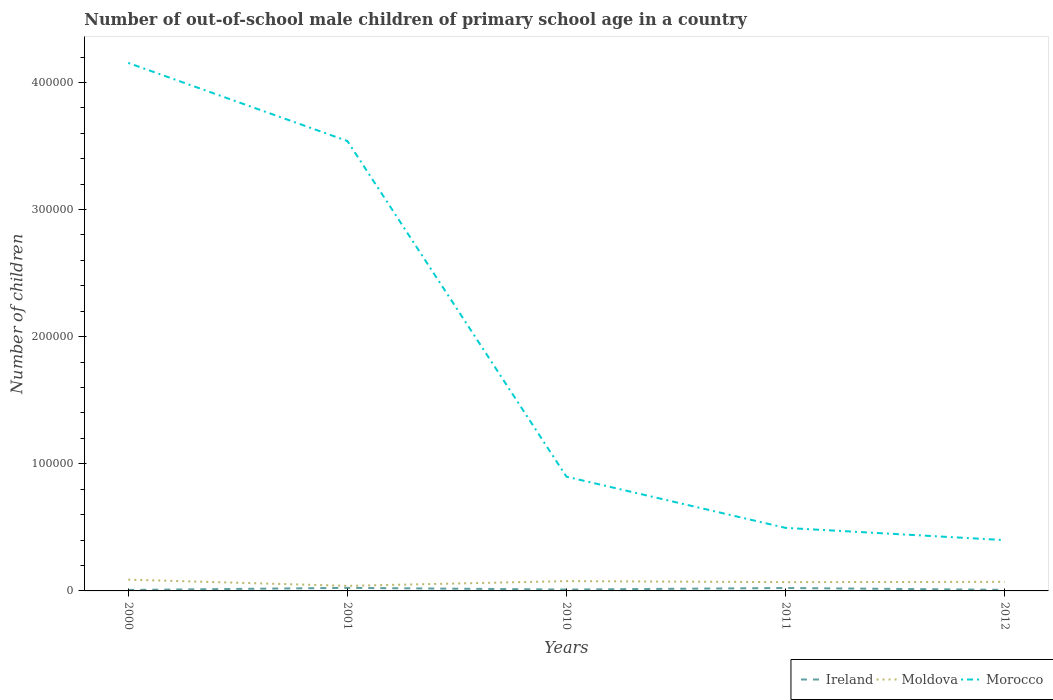Is the number of lines equal to the number of legend labels?
Your answer should be compact. Yes. Across all years, what is the maximum number of out-of-school male children in Ireland?
Offer a terse response. 761. In which year was the number of out-of-school male children in Morocco maximum?
Make the answer very short. 2012. What is the total number of out-of-school male children in Morocco in the graph?
Offer a very short reply. 3.04e+05. What is the difference between the highest and the second highest number of out-of-school male children in Ireland?
Provide a short and direct response. 1641. What is the difference between the highest and the lowest number of out-of-school male children in Moldova?
Make the answer very short. 3. How many lines are there?
Your answer should be compact. 3. What is the difference between two consecutive major ticks on the Y-axis?
Your response must be concise. 1.00e+05. Where does the legend appear in the graph?
Your response must be concise. Bottom right. How many legend labels are there?
Make the answer very short. 3. What is the title of the graph?
Your answer should be compact. Number of out-of-school male children of primary school age in a country. Does "Malaysia" appear as one of the legend labels in the graph?
Keep it short and to the point. No. What is the label or title of the X-axis?
Your answer should be very brief. Years. What is the label or title of the Y-axis?
Your response must be concise. Number of children. What is the Number of children of Ireland in 2000?
Give a very brief answer. 761. What is the Number of children in Moldova in 2000?
Offer a terse response. 8873. What is the Number of children of Morocco in 2000?
Provide a succinct answer. 4.15e+05. What is the Number of children in Ireland in 2001?
Keep it short and to the point. 2402. What is the Number of children of Moldova in 2001?
Make the answer very short. 3993. What is the Number of children of Morocco in 2001?
Your response must be concise. 3.54e+05. What is the Number of children in Ireland in 2010?
Provide a succinct answer. 1077. What is the Number of children in Moldova in 2010?
Offer a very short reply. 7708. What is the Number of children in Morocco in 2010?
Your response must be concise. 8.99e+04. What is the Number of children in Ireland in 2011?
Give a very brief answer. 2292. What is the Number of children in Moldova in 2011?
Your response must be concise. 6917. What is the Number of children of Morocco in 2011?
Your response must be concise. 4.96e+04. What is the Number of children in Ireland in 2012?
Give a very brief answer. 857. What is the Number of children in Moldova in 2012?
Make the answer very short. 7138. What is the Number of children of Morocco in 2012?
Ensure brevity in your answer.  4.00e+04. Across all years, what is the maximum Number of children in Ireland?
Keep it short and to the point. 2402. Across all years, what is the maximum Number of children of Moldova?
Offer a very short reply. 8873. Across all years, what is the maximum Number of children in Morocco?
Your response must be concise. 4.15e+05. Across all years, what is the minimum Number of children in Ireland?
Offer a very short reply. 761. Across all years, what is the minimum Number of children in Moldova?
Provide a short and direct response. 3993. Across all years, what is the minimum Number of children of Morocco?
Provide a short and direct response. 4.00e+04. What is the total Number of children of Ireland in the graph?
Provide a short and direct response. 7389. What is the total Number of children of Moldova in the graph?
Your answer should be compact. 3.46e+04. What is the total Number of children in Morocco in the graph?
Provide a succinct answer. 9.49e+05. What is the difference between the Number of children in Ireland in 2000 and that in 2001?
Provide a short and direct response. -1641. What is the difference between the Number of children of Moldova in 2000 and that in 2001?
Offer a very short reply. 4880. What is the difference between the Number of children of Morocco in 2000 and that in 2001?
Make the answer very short. 6.14e+04. What is the difference between the Number of children of Ireland in 2000 and that in 2010?
Keep it short and to the point. -316. What is the difference between the Number of children of Moldova in 2000 and that in 2010?
Ensure brevity in your answer.  1165. What is the difference between the Number of children in Morocco in 2000 and that in 2010?
Offer a terse response. 3.26e+05. What is the difference between the Number of children in Ireland in 2000 and that in 2011?
Ensure brevity in your answer.  -1531. What is the difference between the Number of children of Moldova in 2000 and that in 2011?
Give a very brief answer. 1956. What is the difference between the Number of children of Morocco in 2000 and that in 2011?
Ensure brevity in your answer.  3.66e+05. What is the difference between the Number of children in Ireland in 2000 and that in 2012?
Make the answer very short. -96. What is the difference between the Number of children in Moldova in 2000 and that in 2012?
Offer a terse response. 1735. What is the difference between the Number of children in Morocco in 2000 and that in 2012?
Make the answer very short. 3.75e+05. What is the difference between the Number of children of Ireland in 2001 and that in 2010?
Provide a succinct answer. 1325. What is the difference between the Number of children in Moldova in 2001 and that in 2010?
Your answer should be very brief. -3715. What is the difference between the Number of children in Morocco in 2001 and that in 2010?
Your answer should be compact. 2.64e+05. What is the difference between the Number of children in Ireland in 2001 and that in 2011?
Your answer should be compact. 110. What is the difference between the Number of children in Moldova in 2001 and that in 2011?
Provide a short and direct response. -2924. What is the difference between the Number of children in Morocco in 2001 and that in 2011?
Provide a succinct answer. 3.04e+05. What is the difference between the Number of children of Ireland in 2001 and that in 2012?
Your answer should be very brief. 1545. What is the difference between the Number of children of Moldova in 2001 and that in 2012?
Provide a succinct answer. -3145. What is the difference between the Number of children in Morocco in 2001 and that in 2012?
Your answer should be very brief. 3.14e+05. What is the difference between the Number of children in Ireland in 2010 and that in 2011?
Offer a terse response. -1215. What is the difference between the Number of children of Moldova in 2010 and that in 2011?
Give a very brief answer. 791. What is the difference between the Number of children of Morocco in 2010 and that in 2011?
Keep it short and to the point. 4.03e+04. What is the difference between the Number of children of Ireland in 2010 and that in 2012?
Give a very brief answer. 220. What is the difference between the Number of children of Moldova in 2010 and that in 2012?
Provide a succinct answer. 570. What is the difference between the Number of children in Morocco in 2010 and that in 2012?
Make the answer very short. 4.99e+04. What is the difference between the Number of children in Ireland in 2011 and that in 2012?
Ensure brevity in your answer.  1435. What is the difference between the Number of children of Moldova in 2011 and that in 2012?
Ensure brevity in your answer.  -221. What is the difference between the Number of children in Morocco in 2011 and that in 2012?
Make the answer very short. 9619. What is the difference between the Number of children of Ireland in 2000 and the Number of children of Moldova in 2001?
Your answer should be compact. -3232. What is the difference between the Number of children in Ireland in 2000 and the Number of children in Morocco in 2001?
Offer a very short reply. -3.53e+05. What is the difference between the Number of children in Moldova in 2000 and the Number of children in Morocco in 2001?
Keep it short and to the point. -3.45e+05. What is the difference between the Number of children of Ireland in 2000 and the Number of children of Moldova in 2010?
Keep it short and to the point. -6947. What is the difference between the Number of children of Ireland in 2000 and the Number of children of Morocco in 2010?
Offer a very short reply. -8.91e+04. What is the difference between the Number of children in Moldova in 2000 and the Number of children in Morocco in 2010?
Give a very brief answer. -8.10e+04. What is the difference between the Number of children of Ireland in 2000 and the Number of children of Moldova in 2011?
Your answer should be compact. -6156. What is the difference between the Number of children in Ireland in 2000 and the Number of children in Morocco in 2011?
Ensure brevity in your answer.  -4.88e+04. What is the difference between the Number of children of Moldova in 2000 and the Number of children of Morocco in 2011?
Give a very brief answer. -4.07e+04. What is the difference between the Number of children of Ireland in 2000 and the Number of children of Moldova in 2012?
Your answer should be very brief. -6377. What is the difference between the Number of children of Ireland in 2000 and the Number of children of Morocco in 2012?
Provide a succinct answer. -3.92e+04. What is the difference between the Number of children in Moldova in 2000 and the Number of children in Morocco in 2012?
Provide a succinct answer. -3.11e+04. What is the difference between the Number of children of Ireland in 2001 and the Number of children of Moldova in 2010?
Give a very brief answer. -5306. What is the difference between the Number of children in Ireland in 2001 and the Number of children in Morocco in 2010?
Make the answer very short. -8.75e+04. What is the difference between the Number of children in Moldova in 2001 and the Number of children in Morocco in 2010?
Make the answer very short. -8.59e+04. What is the difference between the Number of children of Ireland in 2001 and the Number of children of Moldova in 2011?
Offer a very short reply. -4515. What is the difference between the Number of children of Ireland in 2001 and the Number of children of Morocco in 2011?
Keep it short and to the point. -4.72e+04. What is the difference between the Number of children of Moldova in 2001 and the Number of children of Morocco in 2011?
Provide a succinct answer. -4.56e+04. What is the difference between the Number of children in Ireland in 2001 and the Number of children in Moldova in 2012?
Provide a short and direct response. -4736. What is the difference between the Number of children in Ireland in 2001 and the Number of children in Morocco in 2012?
Ensure brevity in your answer.  -3.76e+04. What is the difference between the Number of children of Moldova in 2001 and the Number of children of Morocco in 2012?
Your answer should be very brief. -3.60e+04. What is the difference between the Number of children in Ireland in 2010 and the Number of children in Moldova in 2011?
Keep it short and to the point. -5840. What is the difference between the Number of children in Ireland in 2010 and the Number of children in Morocco in 2011?
Your answer should be very brief. -4.85e+04. What is the difference between the Number of children of Moldova in 2010 and the Number of children of Morocco in 2011?
Your answer should be compact. -4.19e+04. What is the difference between the Number of children in Ireland in 2010 and the Number of children in Moldova in 2012?
Offer a very short reply. -6061. What is the difference between the Number of children in Ireland in 2010 and the Number of children in Morocco in 2012?
Provide a short and direct response. -3.89e+04. What is the difference between the Number of children of Moldova in 2010 and the Number of children of Morocco in 2012?
Ensure brevity in your answer.  -3.23e+04. What is the difference between the Number of children in Ireland in 2011 and the Number of children in Moldova in 2012?
Give a very brief answer. -4846. What is the difference between the Number of children of Ireland in 2011 and the Number of children of Morocco in 2012?
Provide a short and direct response. -3.77e+04. What is the difference between the Number of children of Moldova in 2011 and the Number of children of Morocco in 2012?
Offer a very short reply. -3.31e+04. What is the average Number of children of Ireland per year?
Give a very brief answer. 1477.8. What is the average Number of children in Moldova per year?
Provide a short and direct response. 6925.8. What is the average Number of children in Morocco per year?
Ensure brevity in your answer.  1.90e+05. In the year 2000, what is the difference between the Number of children of Ireland and Number of children of Moldova?
Keep it short and to the point. -8112. In the year 2000, what is the difference between the Number of children of Ireland and Number of children of Morocco?
Provide a short and direct response. -4.15e+05. In the year 2000, what is the difference between the Number of children of Moldova and Number of children of Morocco?
Your answer should be very brief. -4.06e+05. In the year 2001, what is the difference between the Number of children in Ireland and Number of children in Moldova?
Provide a short and direct response. -1591. In the year 2001, what is the difference between the Number of children of Ireland and Number of children of Morocco?
Provide a succinct answer. -3.52e+05. In the year 2001, what is the difference between the Number of children in Moldova and Number of children in Morocco?
Ensure brevity in your answer.  -3.50e+05. In the year 2010, what is the difference between the Number of children in Ireland and Number of children in Moldova?
Provide a short and direct response. -6631. In the year 2010, what is the difference between the Number of children in Ireland and Number of children in Morocco?
Offer a terse response. -8.88e+04. In the year 2010, what is the difference between the Number of children in Moldova and Number of children in Morocco?
Your answer should be very brief. -8.21e+04. In the year 2011, what is the difference between the Number of children in Ireland and Number of children in Moldova?
Offer a very short reply. -4625. In the year 2011, what is the difference between the Number of children of Ireland and Number of children of Morocco?
Offer a very short reply. -4.73e+04. In the year 2011, what is the difference between the Number of children in Moldova and Number of children in Morocco?
Ensure brevity in your answer.  -4.27e+04. In the year 2012, what is the difference between the Number of children of Ireland and Number of children of Moldova?
Make the answer very short. -6281. In the year 2012, what is the difference between the Number of children in Ireland and Number of children in Morocco?
Provide a succinct answer. -3.91e+04. In the year 2012, what is the difference between the Number of children of Moldova and Number of children of Morocco?
Your answer should be very brief. -3.28e+04. What is the ratio of the Number of children in Ireland in 2000 to that in 2001?
Offer a very short reply. 0.32. What is the ratio of the Number of children of Moldova in 2000 to that in 2001?
Keep it short and to the point. 2.22. What is the ratio of the Number of children in Morocco in 2000 to that in 2001?
Provide a short and direct response. 1.17. What is the ratio of the Number of children in Ireland in 2000 to that in 2010?
Provide a succinct answer. 0.71. What is the ratio of the Number of children of Moldova in 2000 to that in 2010?
Ensure brevity in your answer.  1.15. What is the ratio of the Number of children of Morocco in 2000 to that in 2010?
Your answer should be very brief. 4.62. What is the ratio of the Number of children in Ireland in 2000 to that in 2011?
Keep it short and to the point. 0.33. What is the ratio of the Number of children of Moldova in 2000 to that in 2011?
Give a very brief answer. 1.28. What is the ratio of the Number of children of Morocco in 2000 to that in 2011?
Your answer should be very brief. 8.38. What is the ratio of the Number of children in Ireland in 2000 to that in 2012?
Give a very brief answer. 0.89. What is the ratio of the Number of children of Moldova in 2000 to that in 2012?
Offer a terse response. 1.24. What is the ratio of the Number of children in Morocco in 2000 to that in 2012?
Provide a short and direct response. 10.39. What is the ratio of the Number of children of Ireland in 2001 to that in 2010?
Make the answer very short. 2.23. What is the ratio of the Number of children of Moldova in 2001 to that in 2010?
Your response must be concise. 0.52. What is the ratio of the Number of children of Morocco in 2001 to that in 2010?
Keep it short and to the point. 3.94. What is the ratio of the Number of children in Ireland in 2001 to that in 2011?
Ensure brevity in your answer.  1.05. What is the ratio of the Number of children of Moldova in 2001 to that in 2011?
Your answer should be very brief. 0.58. What is the ratio of the Number of children of Morocco in 2001 to that in 2011?
Your response must be concise. 7.14. What is the ratio of the Number of children in Ireland in 2001 to that in 2012?
Make the answer very short. 2.8. What is the ratio of the Number of children in Moldova in 2001 to that in 2012?
Provide a short and direct response. 0.56. What is the ratio of the Number of children in Morocco in 2001 to that in 2012?
Your answer should be very brief. 8.86. What is the ratio of the Number of children of Ireland in 2010 to that in 2011?
Offer a very short reply. 0.47. What is the ratio of the Number of children of Moldova in 2010 to that in 2011?
Provide a short and direct response. 1.11. What is the ratio of the Number of children of Morocco in 2010 to that in 2011?
Ensure brevity in your answer.  1.81. What is the ratio of the Number of children of Ireland in 2010 to that in 2012?
Make the answer very short. 1.26. What is the ratio of the Number of children in Moldova in 2010 to that in 2012?
Make the answer very short. 1.08. What is the ratio of the Number of children in Morocco in 2010 to that in 2012?
Provide a succinct answer. 2.25. What is the ratio of the Number of children of Ireland in 2011 to that in 2012?
Ensure brevity in your answer.  2.67. What is the ratio of the Number of children of Morocco in 2011 to that in 2012?
Your response must be concise. 1.24. What is the difference between the highest and the second highest Number of children of Ireland?
Provide a succinct answer. 110. What is the difference between the highest and the second highest Number of children of Moldova?
Provide a succinct answer. 1165. What is the difference between the highest and the second highest Number of children of Morocco?
Your response must be concise. 6.14e+04. What is the difference between the highest and the lowest Number of children in Ireland?
Make the answer very short. 1641. What is the difference between the highest and the lowest Number of children in Moldova?
Your answer should be very brief. 4880. What is the difference between the highest and the lowest Number of children in Morocco?
Make the answer very short. 3.75e+05. 